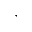Convert formula to latex. <formula><loc_0><loc_0><loc_500><loc_500>,</formula> 